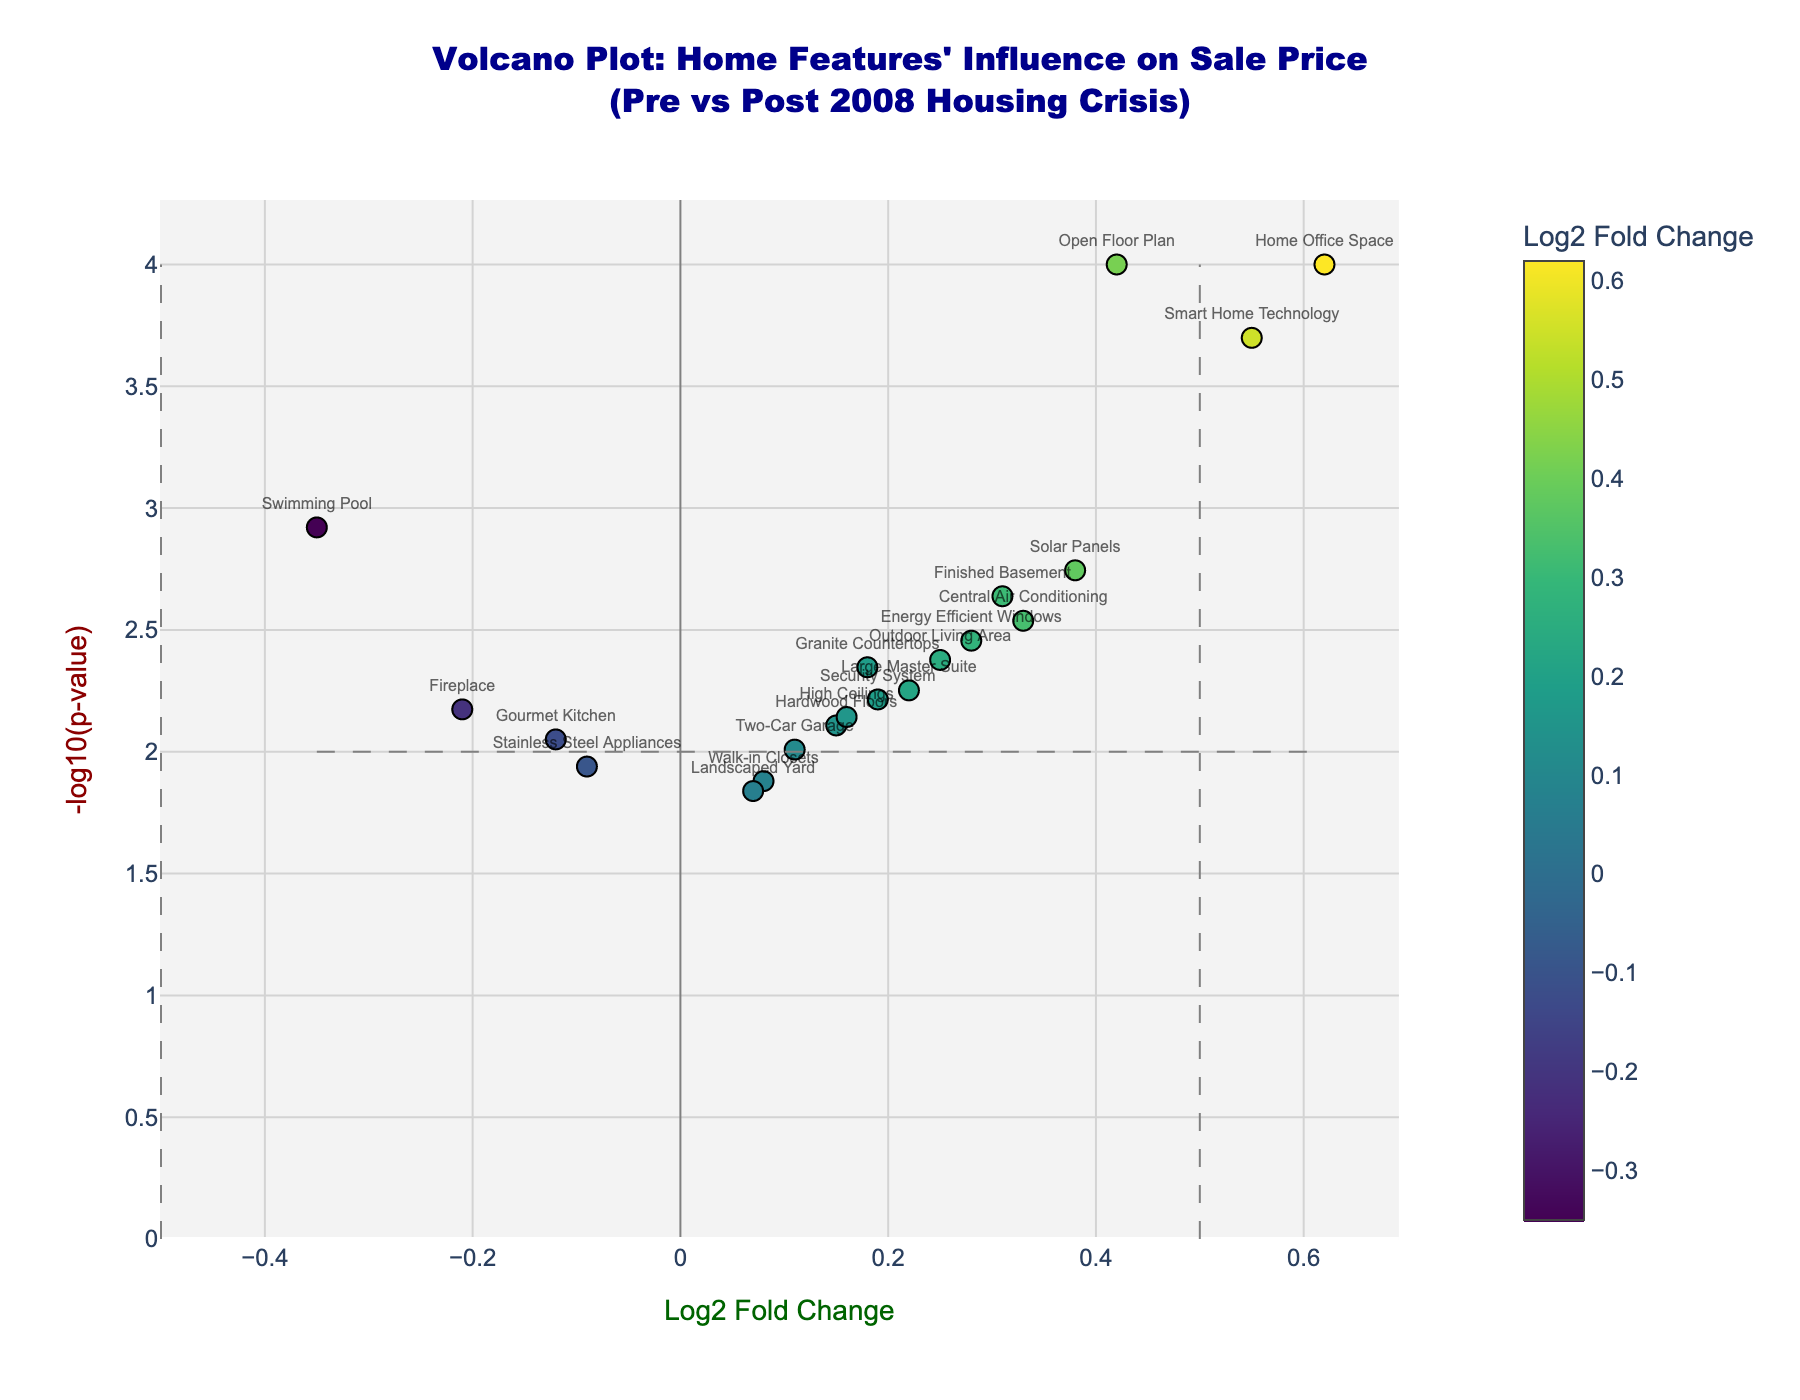What's the title of the plot? The title can be located at the top center of the figure. It provides a summary of what the figure represents. In this case, it reads "Volcano Plot: Home Features' Influence on Sale Price (Pre vs Post 2008 Housing Crisis)".
Answer: "Volcano Plot: Home Features' Influence on Sale Price (Pre vs Post 2008 Housing Crisis)" How is significance represented in the plot? In a volcano plot, statistical significance is typically represented by the y-axis, which in this case is labeled "-log10(p-value)". Higher values on this axis indicate more significant results.
Answer: By -log10(p-value) on the y-axis Which home feature has the highest positive influence on sale price based on the figure? Look for the point with the highest positive Log2 Fold Change on the x-axis. This point is labeled "Home Office Space" and has a Log2 Fold Change of 0.62.
Answer: Home Office Space Which home feature is regarded as least significant based on p-value? The least significant feature would have the lowest value on the y-axis (-log10(p-value)). "Landscaped Yard" has the lowest p-value, indicated by a low -log10(p-value) around 1.8.
Answer: Landscaped Yard Identify any features that show a negative influence on sale price. In the plot, features with a negative Log2 Fold Change on the x-axis show a negative influence. These features include "Swimming Pool", "Gourmet Kitchen", "Fireplace", "Stainless Steel Appliances".
Answer: Swimming Pool, Gourmet Kitchen, Fireplace, Stainless Steel Appliances How many features have a p-value less than 0.01? A p-value of 0.01 corresponds to -log10(p-value) = 2. Count the points above this line. There are 10 features which are above this line.
Answer: 10 features Which two features have nearly identical statistical significance but differing impacts on sale price? Look for points that are at similar y-axis positions but different x-axis positions. "Granite Countertops" and "Outdoor Living Area" are both around -log10(p-value) = 2.35, but have different Log2 Fold Changes of 0.18 and 0.25 respectively.
Answer: Granite Countertops and Outdoor Living Area What is the Fold Change range for the features displayed in the plot? The range of Fold Change is the difference between the maximum and minimum values on the x-axis. Here, the range spans from around -0.35 to 0.62.
Answer: From approximately -0.35 to 0.62 Which feature shows a higher significance but a lower fold change compared to "Finished Basement"? "Finished Basement" has a Log2 Fold Change of 0.31 and -log10(p-value) around 2.64. "Central Air Conditioning" has a lower Fold Change (0.33) but higher significance with a -log10(p-value) of around 2.54.
Answer: Central Air Conditioning 